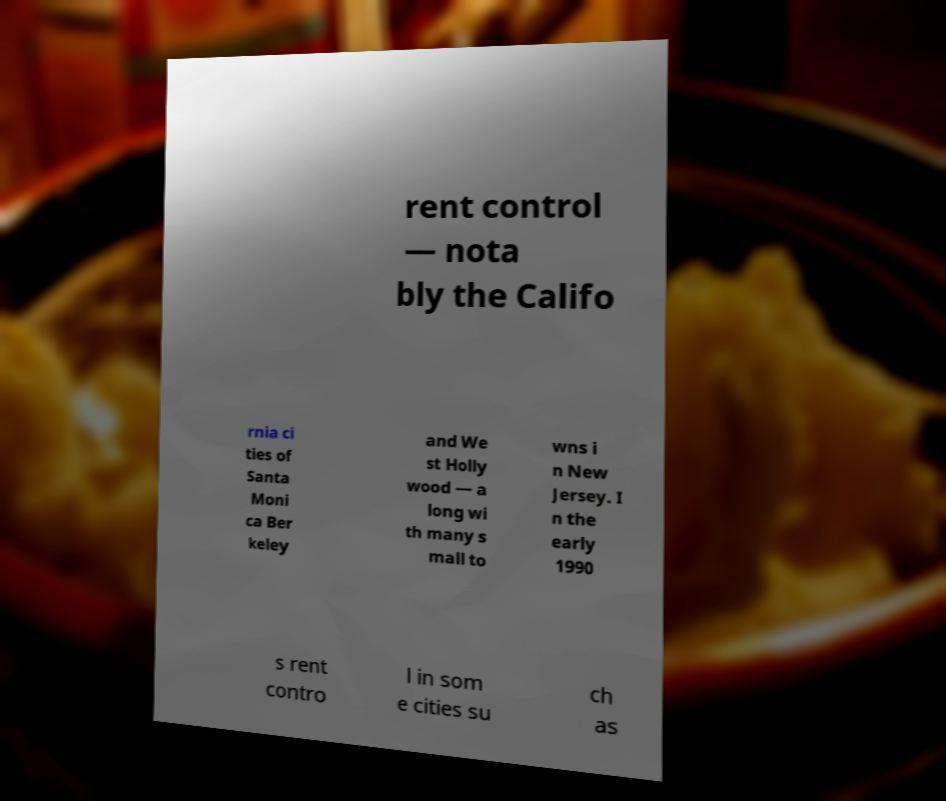Could you extract and type out the text from this image? rent control — nota bly the Califo rnia ci ties of Santa Moni ca Ber keley and We st Holly wood — a long wi th many s mall to wns i n New Jersey. I n the early 1990 s rent contro l in som e cities su ch as 